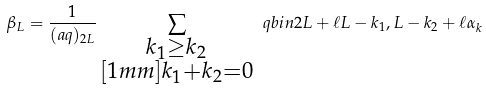Convert formula to latex. <formula><loc_0><loc_0><loc_500><loc_500>\beta _ { L } = \frac { 1 } { ( a q ) _ { 2 L } } \sum _ { \substack { k _ { 1 } \geq k _ { 2 } \\ [ 1 m m ] k _ { 1 } + k _ { 2 } = 0 } } \ q b i n { 2 L + \ell } { L - k _ { 1 } , L - k _ { 2 } + \ell } \alpha _ { k }</formula> 